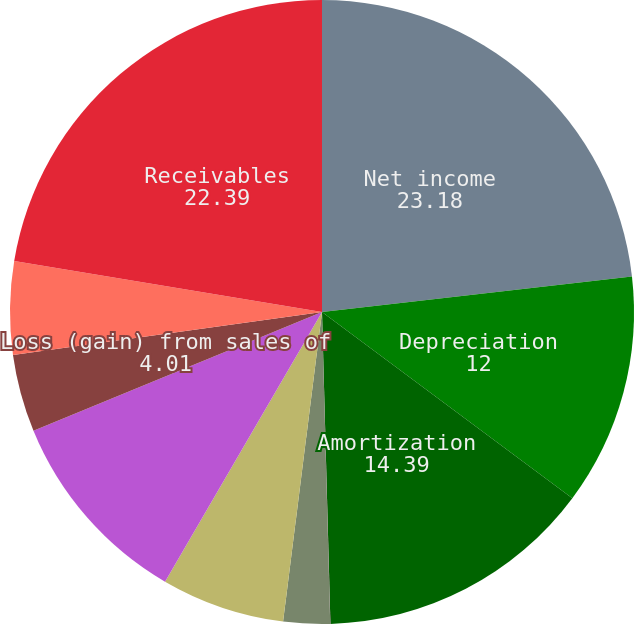<chart> <loc_0><loc_0><loc_500><loc_500><pie_chart><fcel>Net income<fcel>Depreciation<fcel>Amortization<fcel>Goodwill and other asset<fcel>Deferred taxes<fcel>Share-based compensation<fcel>Charges (credits) associated<fcel>Loss (gain) from sales of<fcel>Other non-cash items<fcel>Receivables<nl><fcel>23.18%<fcel>12.0%<fcel>14.39%<fcel>0.01%<fcel>2.41%<fcel>6.4%<fcel>10.4%<fcel>4.01%<fcel>4.81%<fcel>22.39%<nl></chart> 